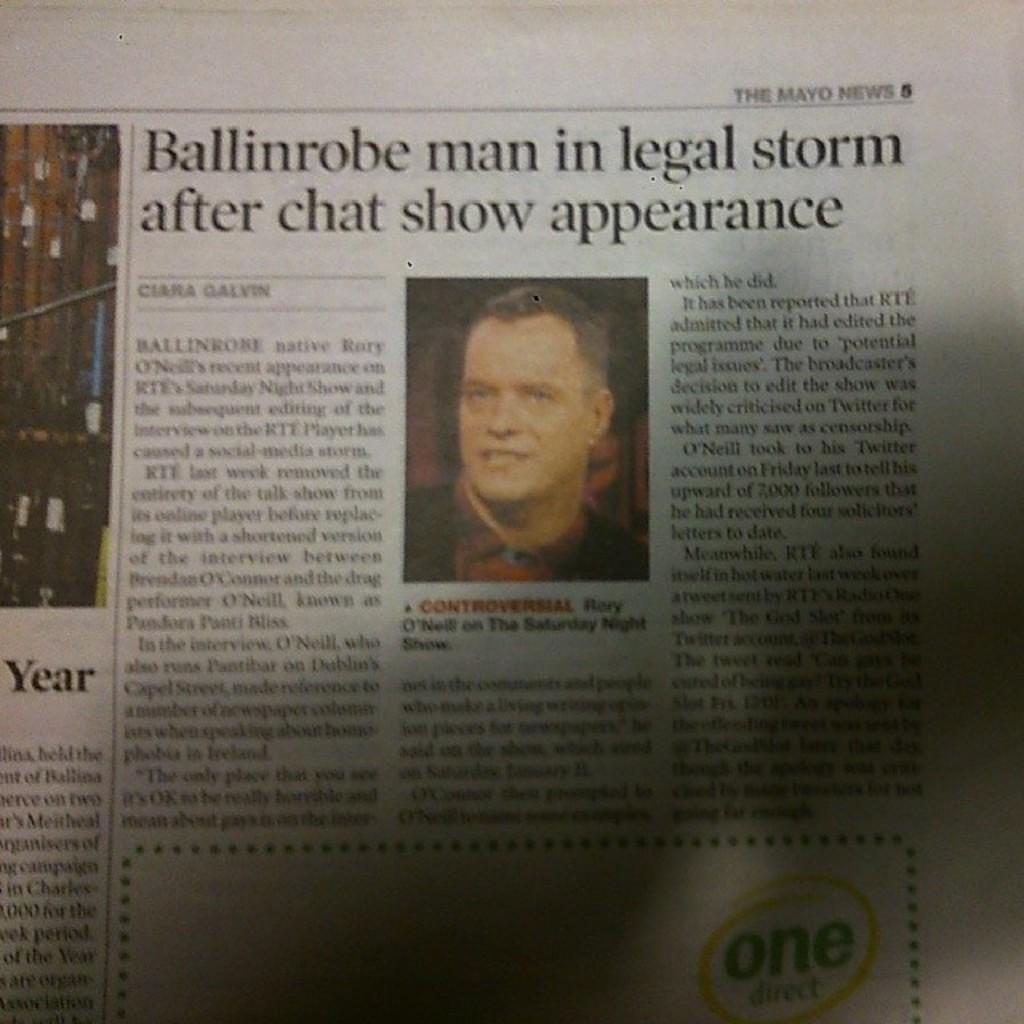Please provide a concise description of this image. In this image I can see a newspaper and something is written with black color. I can see a person face. 